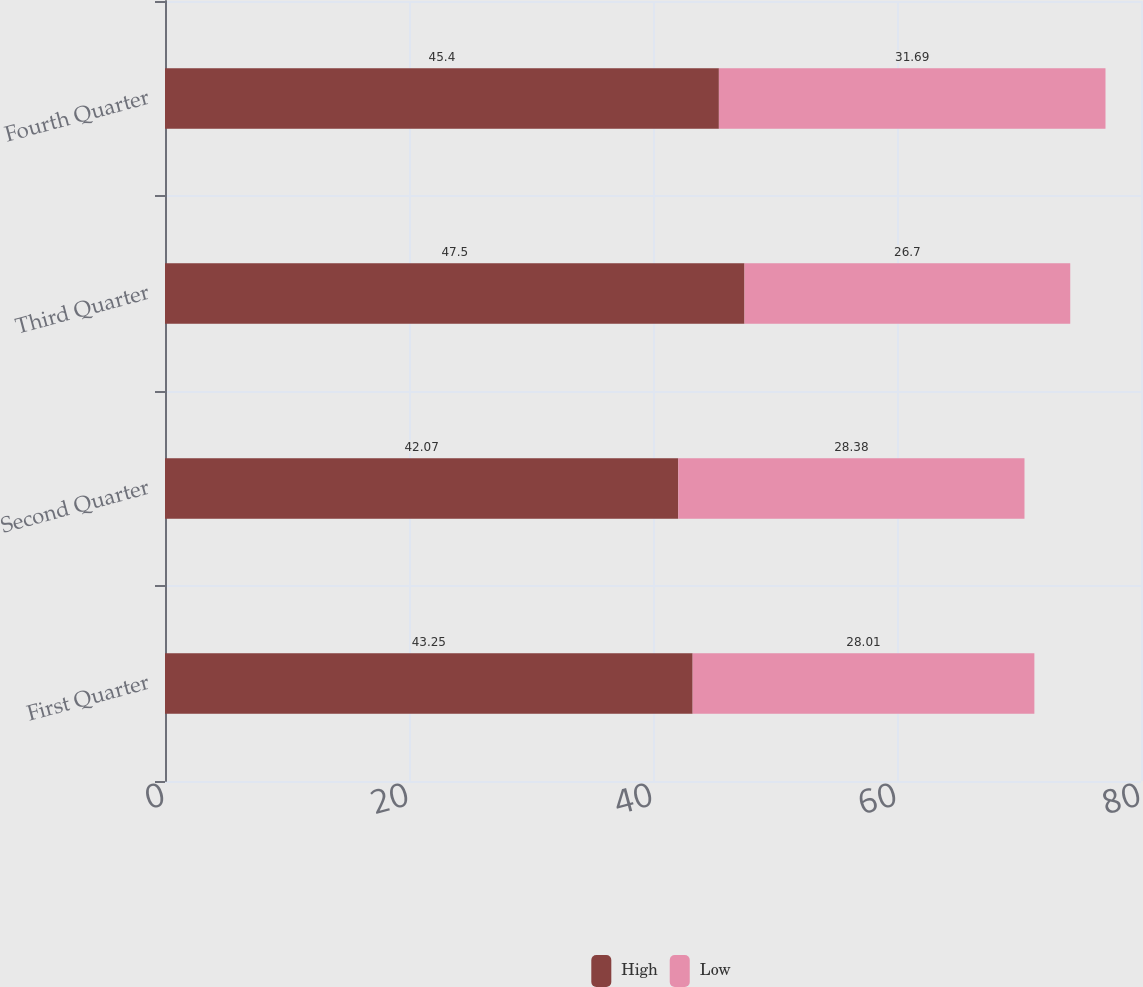Convert chart. <chart><loc_0><loc_0><loc_500><loc_500><stacked_bar_chart><ecel><fcel>First Quarter<fcel>Second Quarter<fcel>Third Quarter<fcel>Fourth Quarter<nl><fcel>High<fcel>43.25<fcel>42.07<fcel>47.5<fcel>45.4<nl><fcel>Low<fcel>28.01<fcel>28.38<fcel>26.7<fcel>31.69<nl></chart> 